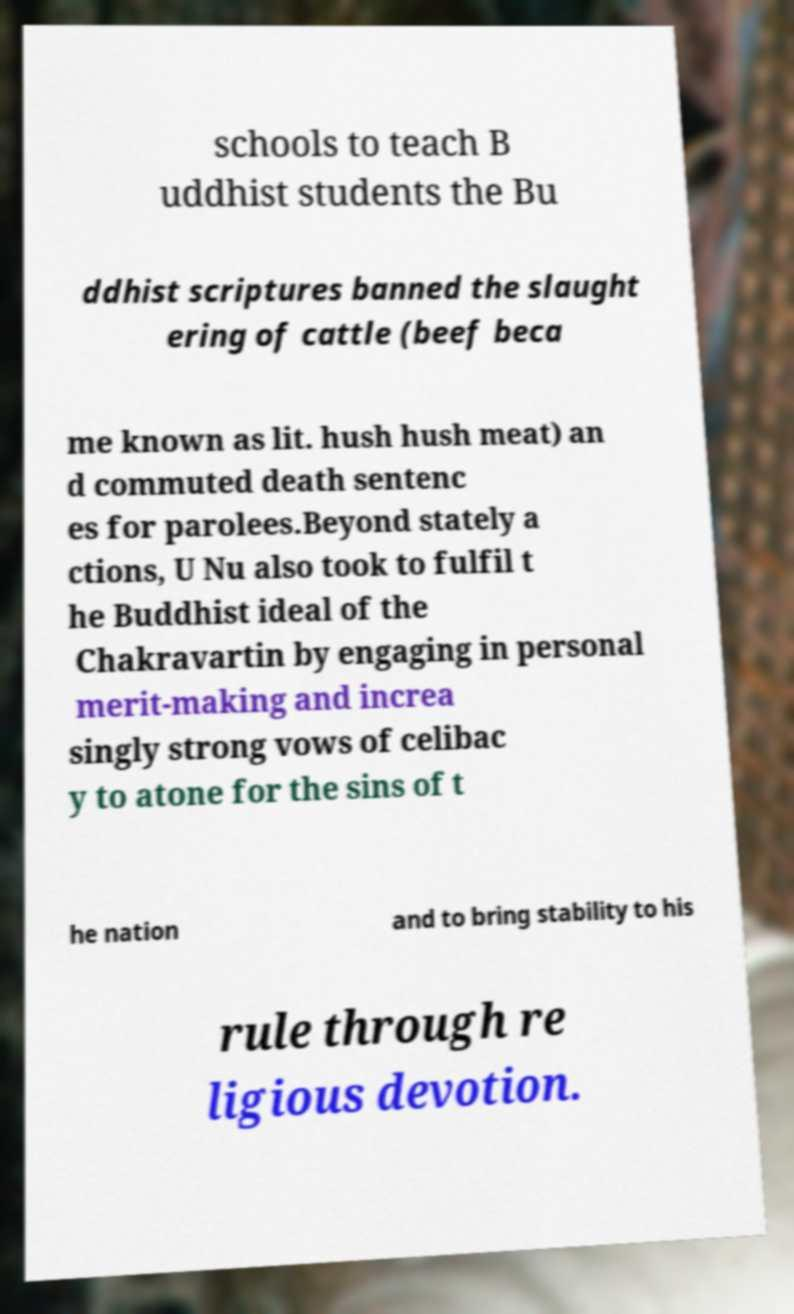For documentation purposes, I need the text within this image transcribed. Could you provide that? schools to teach B uddhist students the Bu ddhist scriptures banned the slaught ering of cattle (beef beca me known as lit. hush hush meat) an d commuted death sentenc es for parolees.Beyond stately a ctions, U Nu also took to fulfil t he Buddhist ideal of the Chakravartin by engaging in personal merit-making and increa singly strong vows of celibac y to atone for the sins of t he nation and to bring stability to his rule through re ligious devotion. 